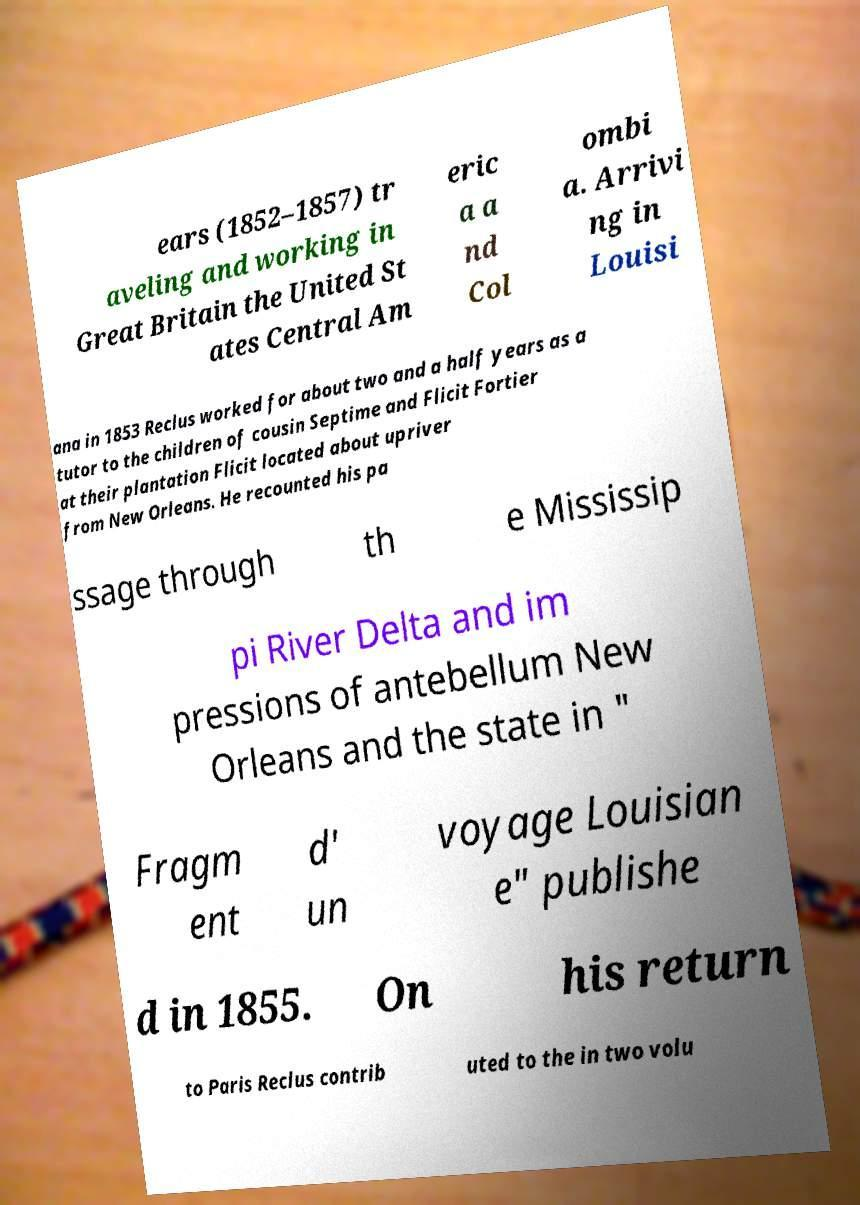Can you accurately transcribe the text from the provided image for me? ears (1852–1857) tr aveling and working in Great Britain the United St ates Central Am eric a a nd Col ombi a. Arrivi ng in Louisi ana in 1853 Reclus worked for about two and a half years as a tutor to the children of cousin Septime and Flicit Fortier at their plantation Flicit located about upriver from New Orleans. He recounted his pa ssage through th e Mississip pi River Delta and im pressions of antebellum New Orleans and the state in " Fragm ent d' un voyage Louisian e" publishe d in 1855. On his return to Paris Reclus contrib uted to the in two volu 